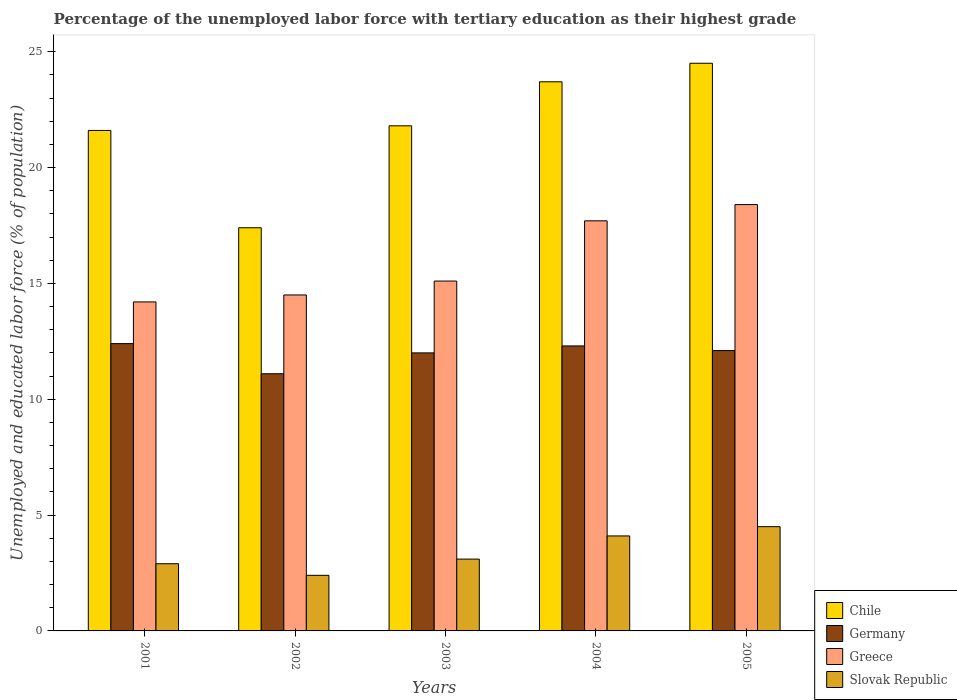How many groups of bars are there?
Provide a short and direct response. 5. Are the number of bars on each tick of the X-axis equal?
Provide a succinct answer. Yes. In how many cases, is the number of bars for a given year not equal to the number of legend labels?
Give a very brief answer. 0. What is the percentage of the unemployed labor force with tertiary education in Germany in 2003?
Your answer should be very brief. 12. Across all years, what is the maximum percentage of the unemployed labor force with tertiary education in Germany?
Make the answer very short. 12.4. Across all years, what is the minimum percentage of the unemployed labor force with tertiary education in Greece?
Provide a succinct answer. 14.2. In which year was the percentage of the unemployed labor force with tertiary education in Germany maximum?
Ensure brevity in your answer.  2001. What is the total percentage of the unemployed labor force with tertiary education in Germany in the graph?
Offer a very short reply. 59.9. What is the difference between the percentage of the unemployed labor force with tertiary education in Greece in 2003 and that in 2005?
Your response must be concise. -3.3. What is the difference between the percentage of the unemployed labor force with tertiary education in Slovak Republic in 2005 and the percentage of the unemployed labor force with tertiary education in Chile in 2003?
Ensure brevity in your answer.  -17.3. What is the average percentage of the unemployed labor force with tertiary education in Greece per year?
Your answer should be very brief. 15.98. In the year 2001, what is the difference between the percentage of the unemployed labor force with tertiary education in Chile and percentage of the unemployed labor force with tertiary education in Slovak Republic?
Your response must be concise. 18.7. In how many years, is the percentage of the unemployed labor force with tertiary education in Slovak Republic greater than 18 %?
Give a very brief answer. 0. What is the ratio of the percentage of the unemployed labor force with tertiary education in Slovak Republic in 2002 to that in 2004?
Offer a very short reply. 0.59. What is the difference between the highest and the second highest percentage of the unemployed labor force with tertiary education in Germany?
Your response must be concise. 0.1. What is the difference between the highest and the lowest percentage of the unemployed labor force with tertiary education in Chile?
Your response must be concise. 7.1. Is the sum of the percentage of the unemployed labor force with tertiary education in Slovak Republic in 2001 and 2005 greater than the maximum percentage of the unemployed labor force with tertiary education in Chile across all years?
Keep it short and to the point. No. Is it the case that in every year, the sum of the percentage of the unemployed labor force with tertiary education in Germany and percentage of the unemployed labor force with tertiary education in Greece is greater than the sum of percentage of the unemployed labor force with tertiary education in Chile and percentage of the unemployed labor force with tertiary education in Slovak Republic?
Provide a succinct answer. Yes. Is it the case that in every year, the sum of the percentage of the unemployed labor force with tertiary education in Slovak Republic and percentage of the unemployed labor force with tertiary education in Greece is greater than the percentage of the unemployed labor force with tertiary education in Germany?
Provide a short and direct response. Yes. How many bars are there?
Your answer should be compact. 20. Are all the bars in the graph horizontal?
Your response must be concise. No. How many years are there in the graph?
Your response must be concise. 5. What is the difference between two consecutive major ticks on the Y-axis?
Keep it short and to the point. 5. Are the values on the major ticks of Y-axis written in scientific E-notation?
Your answer should be very brief. No. Does the graph contain any zero values?
Keep it short and to the point. No. Where does the legend appear in the graph?
Offer a terse response. Bottom right. How many legend labels are there?
Your answer should be very brief. 4. How are the legend labels stacked?
Give a very brief answer. Vertical. What is the title of the graph?
Ensure brevity in your answer.  Percentage of the unemployed labor force with tertiary education as their highest grade. Does "China" appear as one of the legend labels in the graph?
Your response must be concise. No. What is the label or title of the Y-axis?
Give a very brief answer. Unemployed and educated labor force (% of population). What is the Unemployed and educated labor force (% of population) of Chile in 2001?
Make the answer very short. 21.6. What is the Unemployed and educated labor force (% of population) in Germany in 2001?
Offer a very short reply. 12.4. What is the Unemployed and educated labor force (% of population) of Greece in 2001?
Provide a succinct answer. 14.2. What is the Unemployed and educated labor force (% of population) of Slovak Republic in 2001?
Offer a terse response. 2.9. What is the Unemployed and educated labor force (% of population) of Chile in 2002?
Ensure brevity in your answer.  17.4. What is the Unemployed and educated labor force (% of population) of Germany in 2002?
Provide a succinct answer. 11.1. What is the Unemployed and educated labor force (% of population) in Slovak Republic in 2002?
Provide a succinct answer. 2.4. What is the Unemployed and educated labor force (% of population) of Chile in 2003?
Ensure brevity in your answer.  21.8. What is the Unemployed and educated labor force (% of population) of Greece in 2003?
Ensure brevity in your answer.  15.1. What is the Unemployed and educated labor force (% of population) of Slovak Republic in 2003?
Provide a short and direct response. 3.1. What is the Unemployed and educated labor force (% of population) of Chile in 2004?
Keep it short and to the point. 23.7. What is the Unemployed and educated labor force (% of population) of Germany in 2004?
Offer a very short reply. 12.3. What is the Unemployed and educated labor force (% of population) in Greece in 2004?
Keep it short and to the point. 17.7. What is the Unemployed and educated labor force (% of population) of Slovak Republic in 2004?
Keep it short and to the point. 4.1. What is the Unemployed and educated labor force (% of population) of Chile in 2005?
Make the answer very short. 24.5. What is the Unemployed and educated labor force (% of population) of Germany in 2005?
Provide a short and direct response. 12.1. What is the Unemployed and educated labor force (% of population) in Greece in 2005?
Make the answer very short. 18.4. What is the Unemployed and educated labor force (% of population) of Slovak Republic in 2005?
Your response must be concise. 4.5. Across all years, what is the maximum Unemployed and educated labor force (% of population) of Germany?
Keep it short and to the point. 12.4. Across all years, what is the maximum Unemployed and educated labor force (% of population) of Greece?
Your answer should be very brief. 18.4. Across all years, what is the maximum Unemployed and educated labor force (% of population) of Slovak Republic?
Your answer should be very brief. 4.5. Across all years, what is the minimum Unemployed and educated labor force (% of population) in Chile?
Your answer should be compact. 17.4. Across all years, what is the minimum Unemployed and educated labor force (% of population) in Germany?
Provide a short and direct response. 11.1. Across all years, what is the minimum Unemployed and educated labor force (% of population) in Greece?
Make the answer very short. 14.2. Across all years, what is the minimum Unemployed and educated labor force (% of population) in Slovak Republic?
Provide a succinct answer. 2.4. What is the total Unemployed and educated labor force (% of population) in Chile in the graph?
Provide a short and direct response. 109. What is the total Unemployed and educated labor force (% of population) in Germany in the graph?
Make the answer very short. 59.9. What is the total Unemployed and educated labor force (% of population) of Greece in the graph?
Offer a very short reply. 79.9. What is the total Unemployed and educated labor force (% of population) in Slovak Republic in the graph?
Offer a very short reply. 17. What is the difference between the Unemployed and educated labor force (% of population) of Chile in 2001 and that in 2002?
Give a very brief answer. 4.2. What is the difference between the Unemployed and educated labor force (% of population) in Greece in 2001 and that in 2002?
Your response must be concise. -0.3. What is the difference between the Unemployed and educated labor force (% of population) in Slovak Republic in 2001 and that in 2002?
Your answer should be very brief. 0.5. What is the difference between the Unemployed and educated labor force (% of population) of Greece in 2001 and that in 2003?
Your answer should be very brief. -0.9. What is the difference between the Unemployed and educated labor force (% of population) in Chile in 2001 and that in 2004?
Your answer should be compact. -2.1. What is the difference between the Unemployed and educated labor force (% of population) of Slovak Republic in 2001 and that in 2004?
Make the answer very short. -1.2. What is the difference between the Unemployed and educated labor force (% of population) of Slovak Republic in 2001 and that in 2005?
Provide a succinct answer. -1.6. What is the difference between the Unemployed and educated labor force (% of population) of Germany in 2002 and that in 2003?
Give a very brief answer. -0.9. What is the difference between the Unemployed and educated labor force (% of population) of Chile in 2002 and that in 2005?
Offer a terse response. -7.1. What is the difference between the Unemployed and educated labor force (% of population) of Germany in 2002 and that in 2005?
Offer a very short reply. -1. What is the difference between the Unemployed and educated labor force (% of population) of Chile in 2003 and that in 2004?
Provide a succinct answer. -1.9. What is the difference between the Unemployed and educated labor force (% of population) in Slovak Republic in 2003 and that in 2004?
Give a very brief answer. -1. What is the difference between the Unemployed and educated labor force (% of population) of Germany in 2003 and that in 2005?
Offer a very short reply. -0.1. What is the difference between the Unemployed and educated labor force (% of population) of Chile in 2004 and that in 2005?
Provide a short and direct response. -0.8. What is the difference between the Unemployed and educated labor force (% of population) in Germany in 2004 and that in 2005?
Offer a terse response. 0.2. What is the difference between the Unemployed and educated labor force (% of population) of Greece in 2004 and that in 2005?
Keep it short and to the point. -0.7. What is the difference between the Unemployed and educated labor force (% of population) of Slovak Republic in 2004 and that in 2005?
Your answer should be very brief. -0.4. What is the difference between the Unemployed and educated labor force (% of population) in Chile in 2001 and the Unemployed and educated labor force (% of population) in Greece in 2002?
Your answer should be very brief. 7.1. What is the difference between the Unemployed and educated labor force (% of population) in Germany in 2001 and the Unemployed and educated labor force (% of population) in Slovak Republic in 2002?
Offer a terse response. 10. What is the difference between the Unemployed and educated labor force (% of population) of Chile in 2001 and the Unemployed and educated labor force (% of population) of Greece in 2003?
Keep it short and to the point. 6.5. What is the difference between the Unemployed and educated labor force (% of population) in Germany in 2001 and the Unemployed and educated labor force (% of population) in Greece in 2003?
Make the answer very short. -2.7. What is the difference between the Unemployed and educated labor force (% of population) in Germany in 2001 and the Unemployed and educated labor force (% of population) in Slovak Republic in 2003?
Your answer should be very brief. 9.3. What is the difference between the Unemployed and educated labor force (% of population) of Chile in 2001 and the Unemployed and educated labor force (% of population) of Greece in 2004?
Your response must be concise. 3.9. What is the difference between the Unemployed and educated labor force (% of population) in Germany in 2001 and the Unemployed and educated labor force (% of population) in Slovak Republic in 2004?
Ensure brevity in your answer.  8.3. What is the difference between the Unemployed and educated labor force (% of population) of Chile in 2001 and the Unemployed and educated labor force (% of population) of Germany in 2005?
Your response must be concise. 9.5. What is the difference between the Unemployed and educated labor force (% of population) of Chile in 2001 and the Unemployed and educated labor force (% of population) of Greece in 2005?
Provide a short and direct response. 3.2. What is the difference between the Unemployed and educated labor force (% of population) of Germany in 2001 and the Unemployed and educated labor force (% of population) of Greece in 2005?
Ensure brevity in your answer.  -6. What is the difference between the Unemployed and educated labor force (% of population) in Chile in 2002 and the Unemployed and educated labor force (% of population) in Slovak Republic in 2003?
Offer a very short reply. 14.3. What is the difference between the Unemployed and educated labor force (% of population) of Germany in 2002 and the Unemployed and educated labor force (% of population) of Greece in 2003?
Provide a succinct answer. -4. What is the difference between the Unemployed and educated labor force (% of population) in Germany in 2002 and the Unemployed and educated labor force (% of population) in Slovak Republic in 2003?
Offer a terse response. 8. What is the difference between the Unemployed and educated labor force (% of population) of Greece in 2002 and the Unemployed and educated labor force (% of population) of Slovak Republic in 2003?
Make the answer very short. 11.4. What is the difference between the Unemployed and educated labor force (% of population) in Chile in 2002 and the Unemployed and educated labor force (% of population) in Germany in 2004?
Provide a succinct answer. 5.1. What is the difference between the Unemployed and educated labor force (% of population) in Chile in 2002 and the Unemployed and educated labor force (% of population) in Greece in 2004?
Offer a terse response. -0.3. What is the difference between the Unemployed and educated labor force (% of population) of Germany in 2002 and the Unemployed and educated labor force (% of population) of Slovak Republic in 2004?
Your response must be concise. 7. What is the difference between the Unemployed and educated labor force (% of population) in Chile in 2002 and the Unemployed and educated labor force (% of population) in Germany in 2005?
Provide a short and direct response. 5.3. What is the difference between the Unemployed and educated labor force (% of population) of Chile in 2002 and the Unemployed and educated labor force (% of population) of Greece in 2005?
Keep it short and to the point. -1. What is the difference between the Unemployed and educated labor force (% of population) in Greece in 2002 and the Unemployed and educated labor force (% of population) in Slovak Republic in 2005?
Your response must be concise. 10. What is the difference between the Unemployed and educated labor force (% of population) in Chile in 2003 and the Unemployed and educated labor force (% of population) in Germany in 2004?
Offer a terse response. 9.5. What is the difference between the Unemployed and educated labor force (% of population) in Chile in 2003 and the Unemployed and educated labor force (% of population) in Greece in 2004?
Provide a succinct answer. 4.1. What is the difference between the Unemployed and educated labor force (% of population) in Germany in 2003 and the Unemployed and educated labor force (% of population) in Slovak Republic in 2004?
Provide a short and direct response. 7.9. What is the difference between the Unemployed and educated labor force (% of population) of Greece in 2003 and the Unemployed and educated labor force (% of population) of Slovak Republic in 2004?
Offer a terse response. 11. What is the difference between the Unemployed and educated labor force (% of population) in Chile in 2003 and the Unemployed and educated labor force (% of population) in Slovak Republic in 2005?
Offer a terse response. 17.3. What is the difference between the Unemployed and educated labor force (% of population) in Chile in 2004 and the Unemployed and educated labor force (% of population) in Greece in 2005?
Offer a terse response. 5.3. What is the difference between the Unemployed and educated labor force (% of population) of Chile in 2004 and the Unemployed and educated labor force (% of population) of Slovak Republic in 2005?
Keep it short and to the point. 19.2. What is the difference between the Unemployed and educated labor force (% of population) of Germany in 2004 and the Unemployed and educated labor force (% of population) of Slovak Republic in 2005?
Offer a very short reply. 7.8. What is the difference between the Unemployed and educated labor force (% of population) in Greece in 2004 and the Unemployed and educated labor force (% of population) in Slovak Republic in 2005?
Offer a very short reply. 13.2. What is the average Unemployed and educated labor force (% of population) in Chile per year?
Make the answer very short. 21.8. What is the average Unemployed and educated labor force (% of population) of Germany per year?
Provide a succinct answer. 11.98. What is the average Unemployed and educated labor force (% of population) of Greece per year?
Provide a succinct answer. 15.98. In the year 2001, what is the difference between the Unemployed and educated labor force (% of population) in Chile and Unemployed and educated labor force (% of population) in Germany?
Your response must be concise. 9.2. In the year 2001, what is the difference between the Unemployed and educated labor force (% of population) of Chile and Unemployed and educated labor force (% of population) of Slovak Republic?
Offer a terse response. 18.7. In the year 2001, what is the difference between the Unemployed and educated labor force (% of population) of Greece and Unemployed and educated labor force (% of population) of Slovak Republic?
Make the answer very short. 11.3. In the year 2002, what is the difference between the Unemployed and educated labor force (% of population) of Chile and Unemployed and educated labor force (% of population) of Greece?
Ensure brevity in your answer.  2.9. In the year 2002, what is the difference between the Unemployed and educated labor force (% of population) of Chile and Unemployed and educated labor force (% of population) of Slovak Republic?
Provide a short and direct response. 15. In the year 2003, what is the difference between the Unemployed and educated labor force (% of population) in Chile and Unemployed and educated labor force (% of population) in Greece?
Offer a very short reply. 6.7. In the year 2003, what is the difference between the Unemployed and educated labor force (% of population) of Chile and Unemployed and educated labor force (% of population) of Slovak Republic?
Ensure brevity in your answer.  18.7. In the year 2003, what is the difference between the Unemployed and educated labor force (% of population) in Germany and Unemployed and educated labor force (% of population) in Slovak Republic?
Make the answer very short. 8.9. In the year 2004, what is the difference between the Unemployed and educated labor force (% of population) of Chile and Unemployed and educated labor force (% of population) of Germany?
Make the answer very short. 11.4. In the year 2004, what is the difference between the Unemployed and educated labor force (% of population) of Chile and Unemployed and educated labor force (% of population) of Greece?
Your response must be concise. 6. In the year 2004, what is the difference between the Unemployed and educated labor force (% of population) in Chile and Unemployed and educated labor force (% of population) in Slovak Republic?
Offer a very short reply. 19.6. In the year 2004, what is the difference between the Unemployed and educated labor force (% of population) of Germany and Unemployed and educated labor force (% of population) of Greece?
Ensure brevity in your answer.  -5.4. In the year 2004, what is the difference between the Unemployed and educated labor force (% of population) of Germany and Unemployed and educated labor force (% of population) of Slovak Republic?
Offer a terse response. 8.2. In the year 2004, what is the difference between the Unemployed and educated labor force (% of population) in Greece and Unemployed and educated labor force (% of population) in Slovak Republic?
Ensure brevity in your answer.  13.6. In the year 2005, what is the difference between the Unemployed and educated labor force (% of population) in Chile and Unemployed and educated labor force (% of population) in Slovak Republic?
Offer a terse response. 20. In the year 2005, what is the difference between the Unemployed and educated labor force (% of population) of Germany and Unemployed and educated labor force (% of population) of Slovak Republic?
Provide a succinct answer. 7.6. In the year 2005, what is the difference between the Unemployed and educated labor force (% of population) in Greece and Unemployed and educated labor force (% of population) in Slovak Republic?
Keep it short and to the point. 13.9. What is the ratio of the Unemployed and educated labor force (% of population) in Chile in 2001 to that in 2002?
Ensure brevity in your answer.  1.24. What is the ratio of the Unemployed and educated labor force (% of population) of Germany in 2001 to that in 2002?
Provide a short and direct response. 1.12. What is the ratio of the Unemployed and educated labor force (% of population) in Greece in 2001 to that in 2002?
Make the answer very short. 0.98. What is the ratio of the Unemployed and educated labor force (% of population) of Slovak Republic in 2001 to that in 2002?
Give a very brief answer. 1.21. What is the ratio of the Unemployed and educated labor force (% of population) in Germany in 2001 to that in 2003?
Provide a short and direct response. 1.03. What is the ratio of the Unemployed and educated labor force (% of population) of Greece in 2001 to that in 2003?
Offer a very short reply. 0.94. What is the ratio of the Unemployed and educated labor force (% of population) of Slovak Republic in 2001 to that in 2003?
Provide a short and direct response. 0.94. What is the ratio of the Unemployed and educated labor force (% of population) of Chile in 2001 to that in 2004?
Give a very brief answer. 0.91. What is the ratio of the Unemployed and educated labor force (% of population) in Germany in 2001 to that in 2004?
Your answer should be compact. 1.01. What is the ratio of the Unemployed and educated labor force (% of population) of Greece in 2001 to that in 2004?
Offer a very short reply. 0.8. What is the ratio of the Unemployed and educated labor force (% of population) of Slovak Republic in 2001 to that in 2004?
Provide a succinct answer. 0.71. What is the ratio of the Unemployed and educated labor force (% of population) of Chile in 2001 to that in 2005?
Your response must be concise. 0.88. What is the ratio of the Unemployed and educated labor force (% of population) of Germany in 2001 to that in 2005?
Your answer should be compact. 1.02. What is the ratio of the Unemployed and educated labor force (% of population) in Greece in 2001 to that in 2005?
Make the answer very short. 0.77. What is the ratio of the Unemployed and educated labor force (% of population) of Slovak Republic in 2001 to that in 2005?
Offer a very short reply. 0.64. What is the ratio of the Unemployed and educated labor force (% of population) of Chile in 2002 to that in 2003?
Provide a short and direct response. 0.8. What is the ratio of the Unemployed and educated labor force (% of population) of Germany in 2002 to that in 2003?
Provide a succinct answer. 0.93. What is the ratio of the Unemployed and educated labor force (% of population) of Greece in 2002 to that in 2003?
Make the answer very short. 0.96. What is the ratio of the Unemployed and educated labor force (% of population) of Slovak Republic in 2002 to that in 2003?
Your response must be concise. 0.77. What is the ratio of the Unemployed and educated labor force (% of population) in Chile in 2002 to that in 2004?
Your answer should be compact. 0.73. What is the ratio of the Unemployed and educated labor force (% of population) in Germany in 2002 to that in 2004?
Keep it short and to the point. 0.9. What is the ratio of the Unemployed and educated labor force (% of population) of Greece in 2002 to that in 2004?
Ensure brevity in your answer.  0.82. What is the ratio of the Unemployed and educated labor force (% of population) of Slovak Republic in 2002 to that in 2004?
Your answer should be very brief. 0.59. What is the ratio of the Unemployed and educated labor force (% of population) of Chile in 2002 to that in 2005?
Offer a very short reply. 0.71. What is the ratio of the Unemployed and educated labor force (% of population) of Germany in 2002 to that in 2005?
Your answer should be compact. 0.92. What is the ratio of the Unemployed and educated labor force (% of population) in Greece in 2002 to that in 2005?
Make the answer very short. 0.79. What is the ratio of the Unemployed and educated labor force (% of population) of Slovak Republic in 2002 to that in 2005?
Offer a very short reply. 0.53. What is the ratio of the Unemployed and educated labor force (% of population) of Chile in 2003 to that in 2004?
Keep it short and to the point. 0.92. What is the ratio of the Unemployed and educated labor force (% of population) in Germany in 2003 to that in 2004?
Your response must be concise. 0.98. What is the ratio of the Unemployed and educated labor force (% of population) of Greece in 2003 to that in 2004?
Your answer should be very brief. 0.85. What is the ratio of the Unemployed and educated labor force (% of population) in Slovak Republic in 2003 to that in 2004?
Ensure brevity in your answer.  0.76. What is the ratio of the Unemployed and educated labor force (% of population) in Chile in 2003 to that in 2005?
Your answer should be very brief. 0.89. What is the ratio of the Unemployed and educated labor force (% of population) in Germany in 2003 to that in 2005?
Offer a very short reply. 0.99. What is the ratio of the Unemployed and educated labor force (% of population) of Greece in 2003 to that in 2005?
Make the answer very short. 0.82. What is the ratio of the Unemployed and educated labor force (% of population) in Slovak Republic in 2003 to that in 2005?
Make the answer very short. 0.69. What is the ratio of the Unemployed and educated labor force (% of population) in Chile in 2004 to that in 2005?
Your answer should be compact. 0.97. What is the ratio of the Unemployed and educated labor force (% of population) of Germany in 2004 to that in 2005?
Ensure brevity in your answer.  1.02. What is the ratio of the Unemployed and educated labor force (% of population) in Greece in 2004 to that in 2005?
Provide a succinct answer. 0.96. What is the ratio of the Unemployed and educated labor force (% of population) in Slovak Republic in 2004 to that in 2005?
Ensure brevity in your answer.  0.91. What is the difference between the highest and the second highest Unemployed and educated labor force (% of population) in Chile?
Keep it short and to the point. 0.8. What is the difference between the highest and the second highest Unemployed and educated labor force (% of population) in Greece?
Make the answer very short. 0.7. What is the difference between the highest and the lowest Unemployed and educated labor force (% of population) of Chile?
Offer a very short reply. 7.1. What is the difference between the highest and the lowest Unemployed and educated labor force (% of population) in Greece?
Your response must be concise. 4.2. What is the difference between the highest and the lowest Unemployed and educated labor force (% of population) in Slovak Republic?
Offer a terse response. 2.1. 